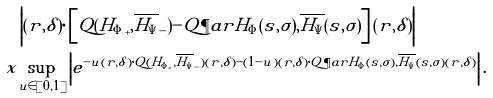<formula> <loc_0><loc_0><loc_500><loc_500>& \left | ( r , \delta ) \cdot \left [ Q ( { H _ { \Phi } } _ { + } , \overline { H _ { \Psi } } _ { - } ) - Q \P a r { H _ { \Phi } ( s , \sigma ) , \overline { H _ { \Psi } } ( s , \sigma ) } \right ] ( r , \delta ) \right | \\ \ x & \underset { u \in [ 0 , 1 ] } { \sup } \left | e ^ { - u ( r , \delta ) \cdot Q ( { H _ { \Phi } } _ { + } , \overline { H _ { \Psi } } _ { - } ) ( r , \delta ) - ( 1 - u ) ( r , \delta ) \cdot Q \P a r { H _ { \Phi } ( s , \sigma ) , \overline { H _ { \Psi } } ( s , \sigma ) } ( r , \delta ) } \right | .</formula> 